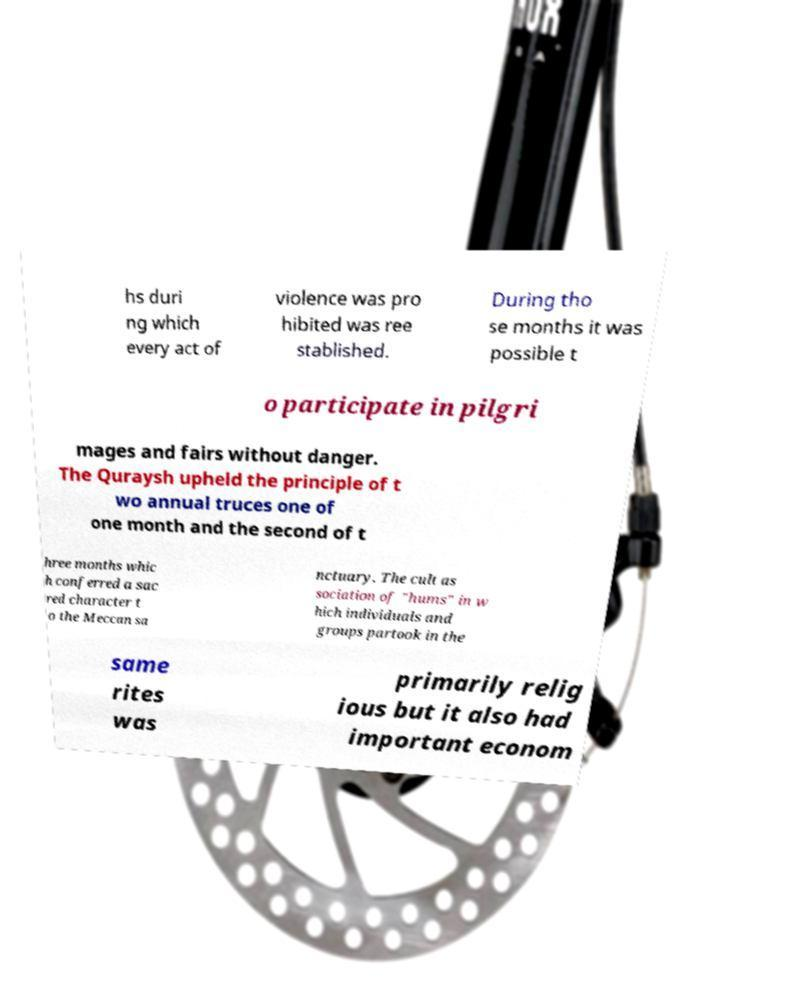Can you accurately transcribe the text from the provided image for me? hs duri ng which every act of violence was pro hibited was ree stablished. During tho se months it was possible t o participate in pilgri mages and fairs without danger. The Quraysh upheld the principle of t wo annual truces one of one month and the second of t hree months whic h conferred a sac red character t o the Meccan sa nctuary. The cult as sociation of "hums" in w hich individuals and groups partook in the same rites was primarily relig ious but it also had important econom 